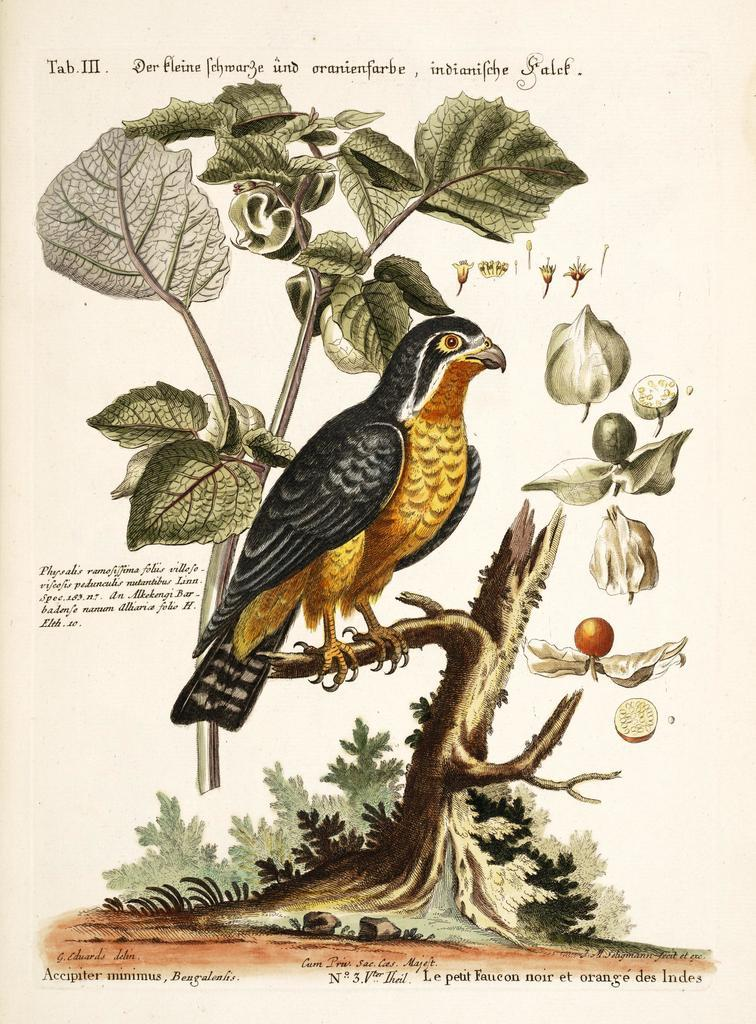What is on the paper in the image? The paper in the image contains words and numbers, as well as a photo of a tree trunk. What can be seen in the photo on the paper? In the photo, there are plants, fruits, leaves, and a bird. What flavor of ice cream is the bird eating in the image? There is no ice cream present in the image, and therefore no bird is eating ice cream. 